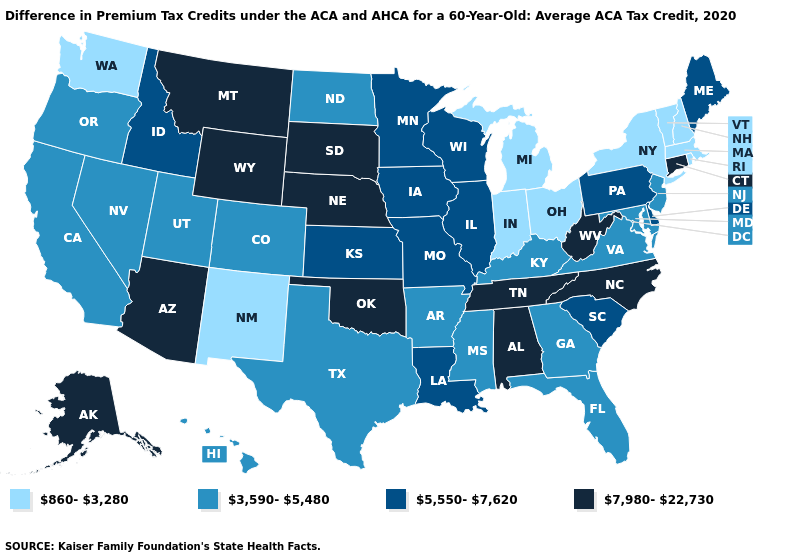Name the states that have a value in the range 5,550-7,620?
Quick response, please. Delaware, Idaho, Illinois, Iowa, Kansas, Louisiana, Maine, Minnesota, Missouri, Pennsylvania, South Carolina, Wisconsin. Name the states that have a value in the range 3,590-5,480?
Keep it brief. Arkansas, California, Colorado, Florida, Georgia, Hawaii, Kentucky, Maryland, Mississippi, Nevada, New Jersey, North Dakota, Oregon, Texas, Utah, Virginia. What is the highest value in the South ?
Give a very brief answer. 7,980-22,730. Which states have the lowest value in the USA?
Be succinct. Indiana, Massachusetts, Michigan, New Hampshire, New Mexico, New York, Ohio, Rhode Island, Vermont, Washington. What is the value of Nevada?
Give a very brief answer. 3,590-5,480. Name the states that have a value in the range 5,550-7,620?
Concise answer only. Delaware, Idaho, Illinois, Iowa, Kansas, Louisiana, Maine, Minnesota, Missouri, Pennsylvania, South Carolina, Wisconsin. Does the first symbol in the legend represent the smallest category?
Quick response, please. Yes. What is the value of Minnesota?
Be succinct. 5,550-7,620. Which states have the lowest value in the USA?
Concise answer only. Indiana, Massachusetts, Michigan, New Hampshire, New Mexico, New York, Ohio, Rhode Island, Vermont, Washington. Does Maryland have the same value as Kentucky?
Be succinct. Yes. Does the map have missing data?
Answer briefly. No. Among the states that border Wyoming , which have the highest value?
Give a very brief answer. Montana, Nebraska, South Dakota. Name the states that have a value in the range 5,550-7,620?
Short answer required. Delaware, Idaho, Illinois, Iowa, Kansas, Louisiana, Maine, Minnesota, Missouri, Pennsylvania, South Carolina, Wisconsin. Does New York have the lowest value in the Northeast?
Write a very short answer. Yes. 